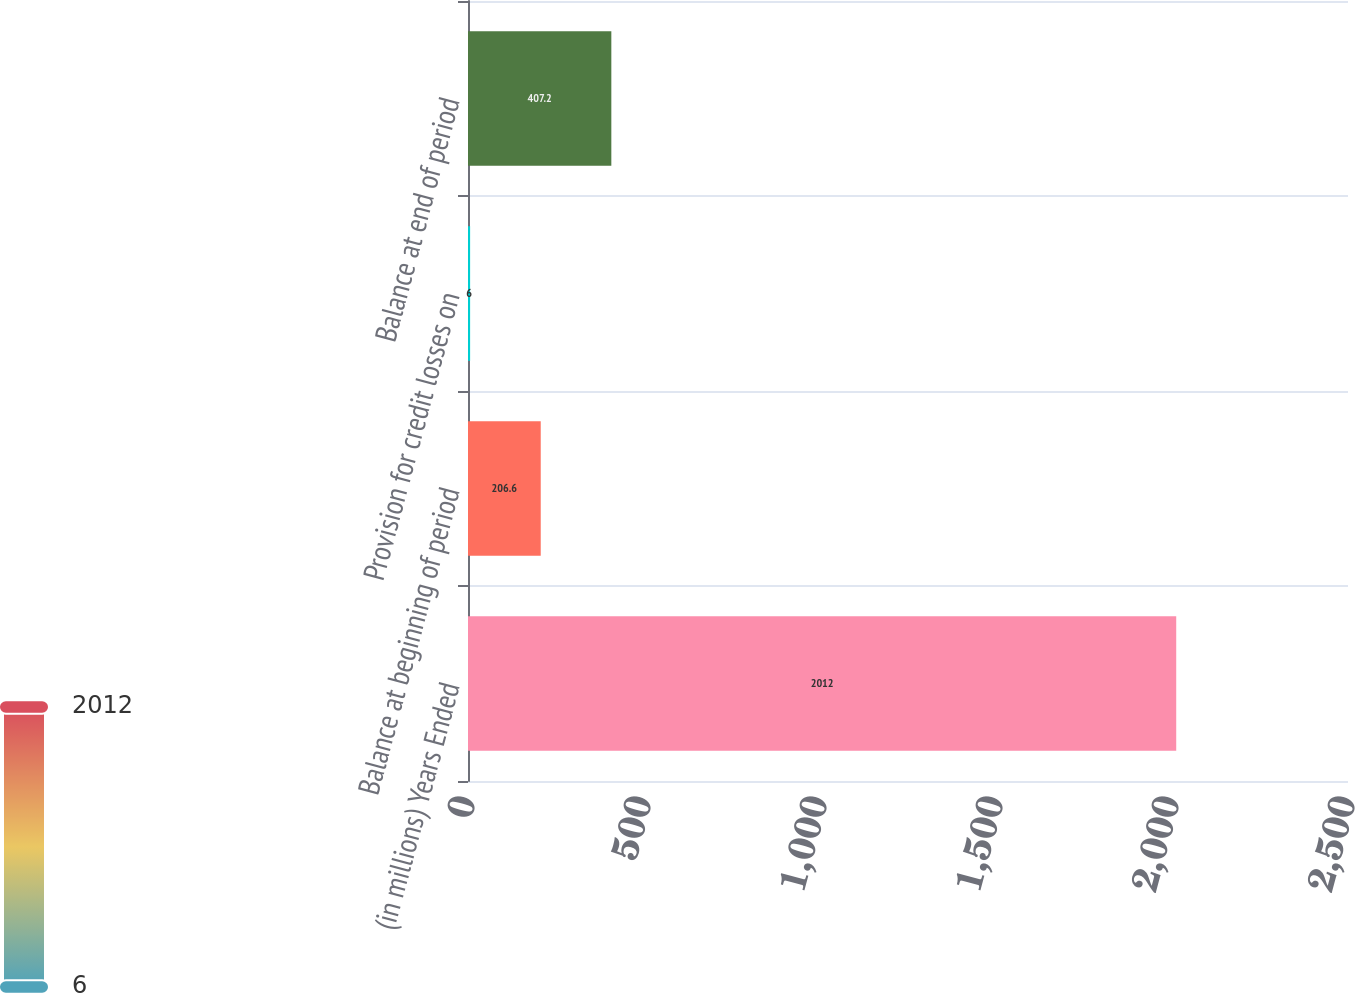Convert chart to OTSL. <chart><loc_0><loc_0><loc_500><loc_500><bar_chart><fcel>(in millions) Years Ended<fcel>Balance at beginning of period<fcel>Provision for credit losses on<fcel>Balance at end of period<nl><fcel>2012<fcel>206.6<fcel>6<fcel>407.2<nl></chart> 